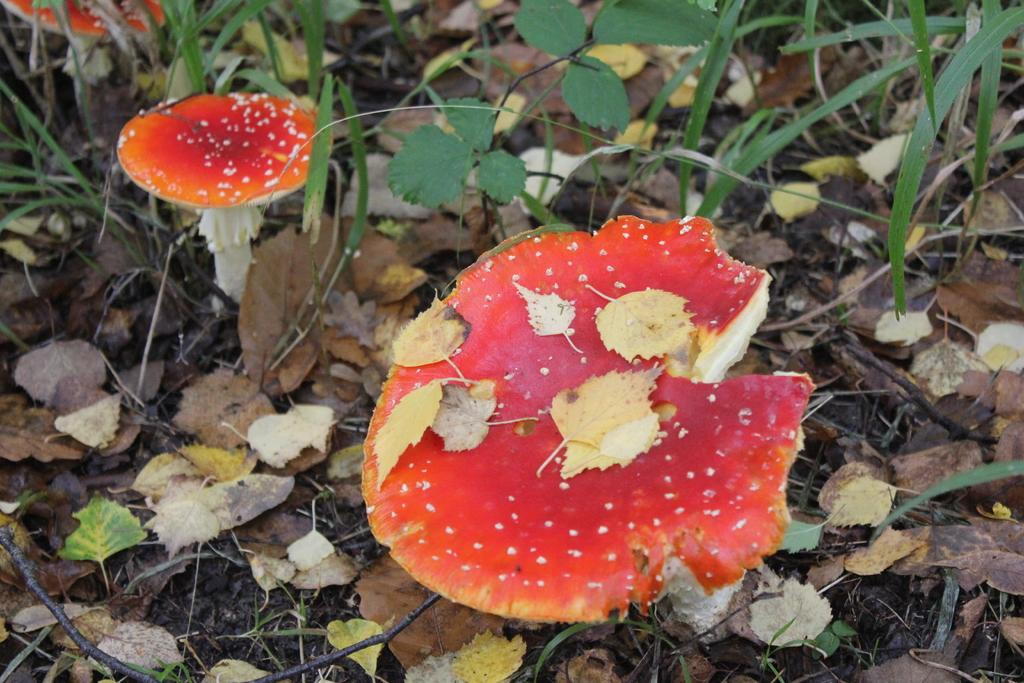What type of fungi can be seen in the image? There are mushrooms in the image. Where are the mushrooms located? The mushrooms are on dry grassland. What design is featured on the horn of the animal in the image? There is no animal or horn present in the image; it only features mushrooms on dry grassland. 